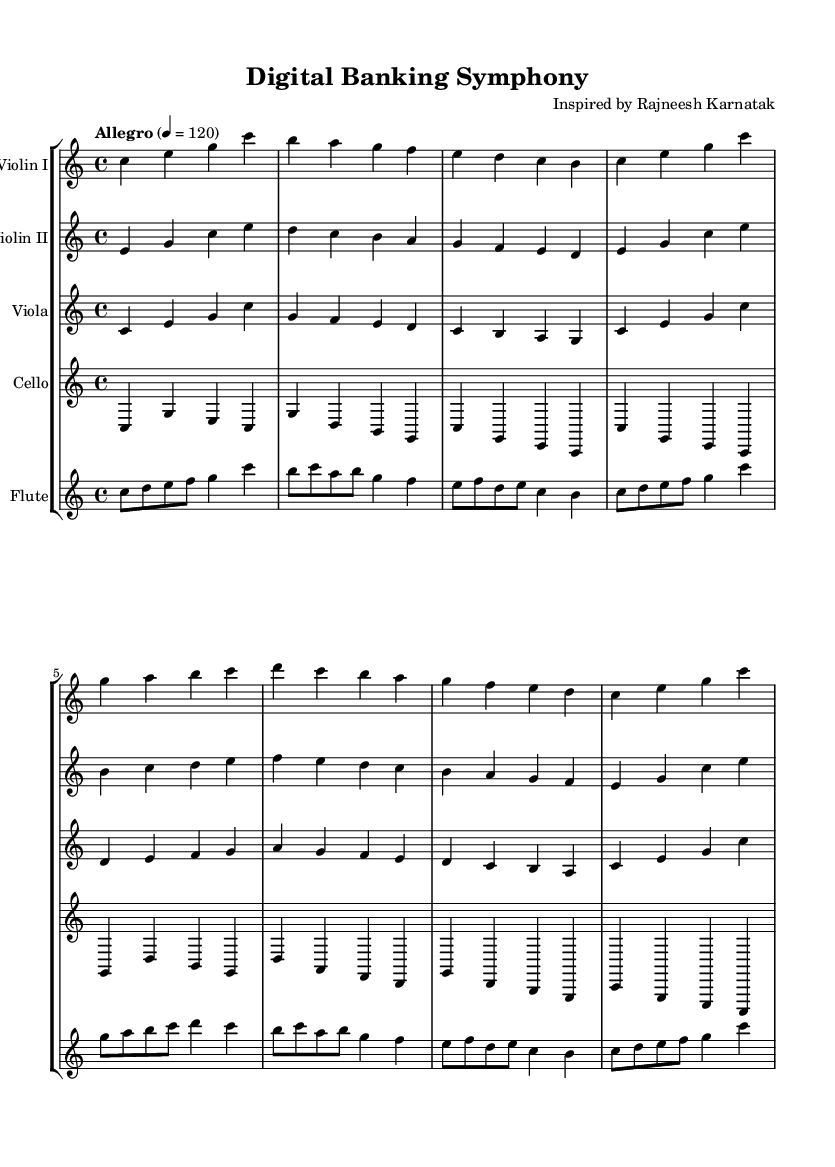What is the key signature of this music? The key signature indicated at the beginning of the music is C major, which has no sharps or flats as seen in the notation.
Answer: C major What is the time signature of this music? The time signature is written as "4/4" at the beginning of the score, which indicates four beats per measure.
Answer: 4/4 What is the tempo marking for this piece? The tempo marking written in the score is "Allegro" with a metronome marking of 120, which suggests a fast-paced performance.
Answer: Allegro, 120 How many measures are in the Violin I part? By counting the measures in the Violin I part written in the score, there are a total of 8 measures.
Answer: 8 Which instrument plays the highest pitch in this excerpt? The Flute typically plays higher than the strings, and by evaluating the notes, the Flute section has the highest pitch, especially in the ascending phrases.
Answer: Flute In which instrument section does the melody predominantly reside? Looking at the various parts, the melody primarily resides in the Violet I, as it frequently carries the main thematic material throughout the symphony.
Answer: Violin I How does the Cello part interact with the other instruments? The Cello part often provides a harmonic foundation and fills in lower registers, thus complementing the higher voices like the Violins and Flute by creating balance within the ensemble.
Answer: Supports harmonic foundation 